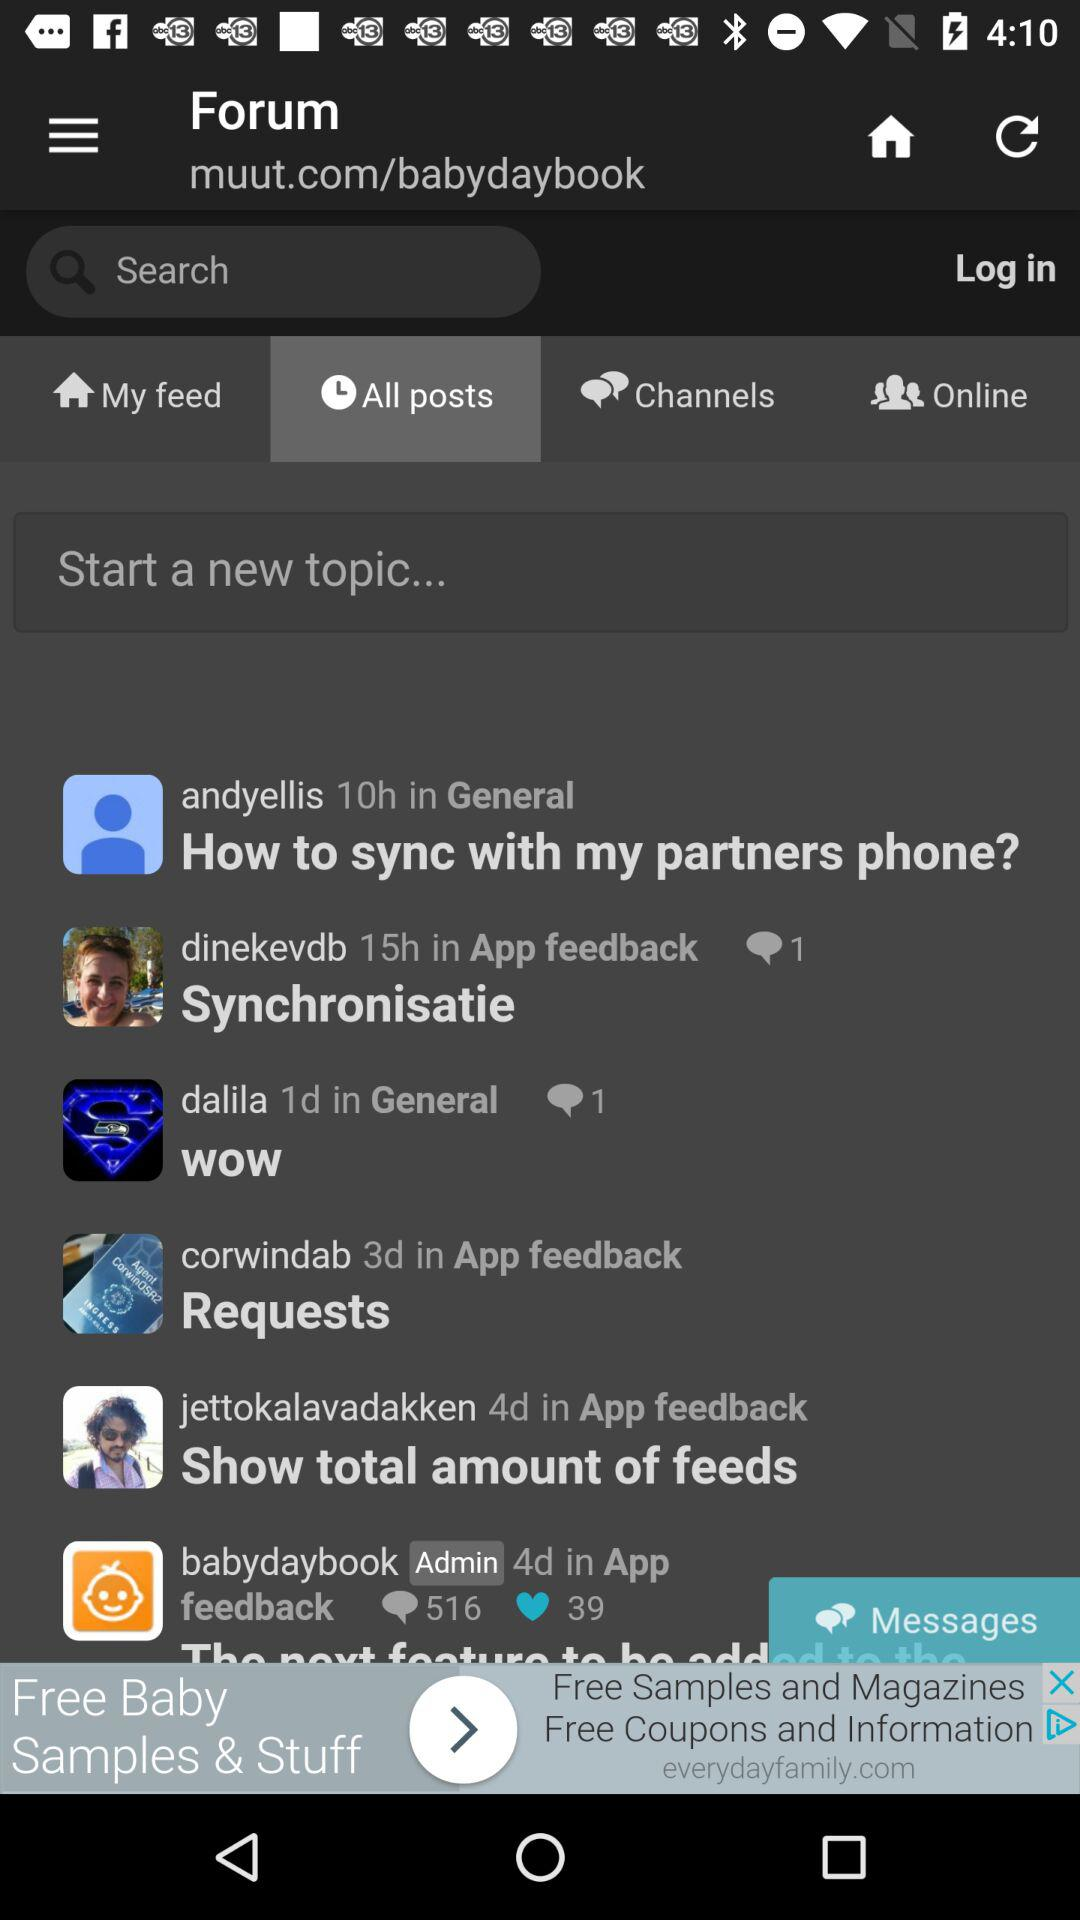Which tab is currently selected? The selected tab is "All posts". 